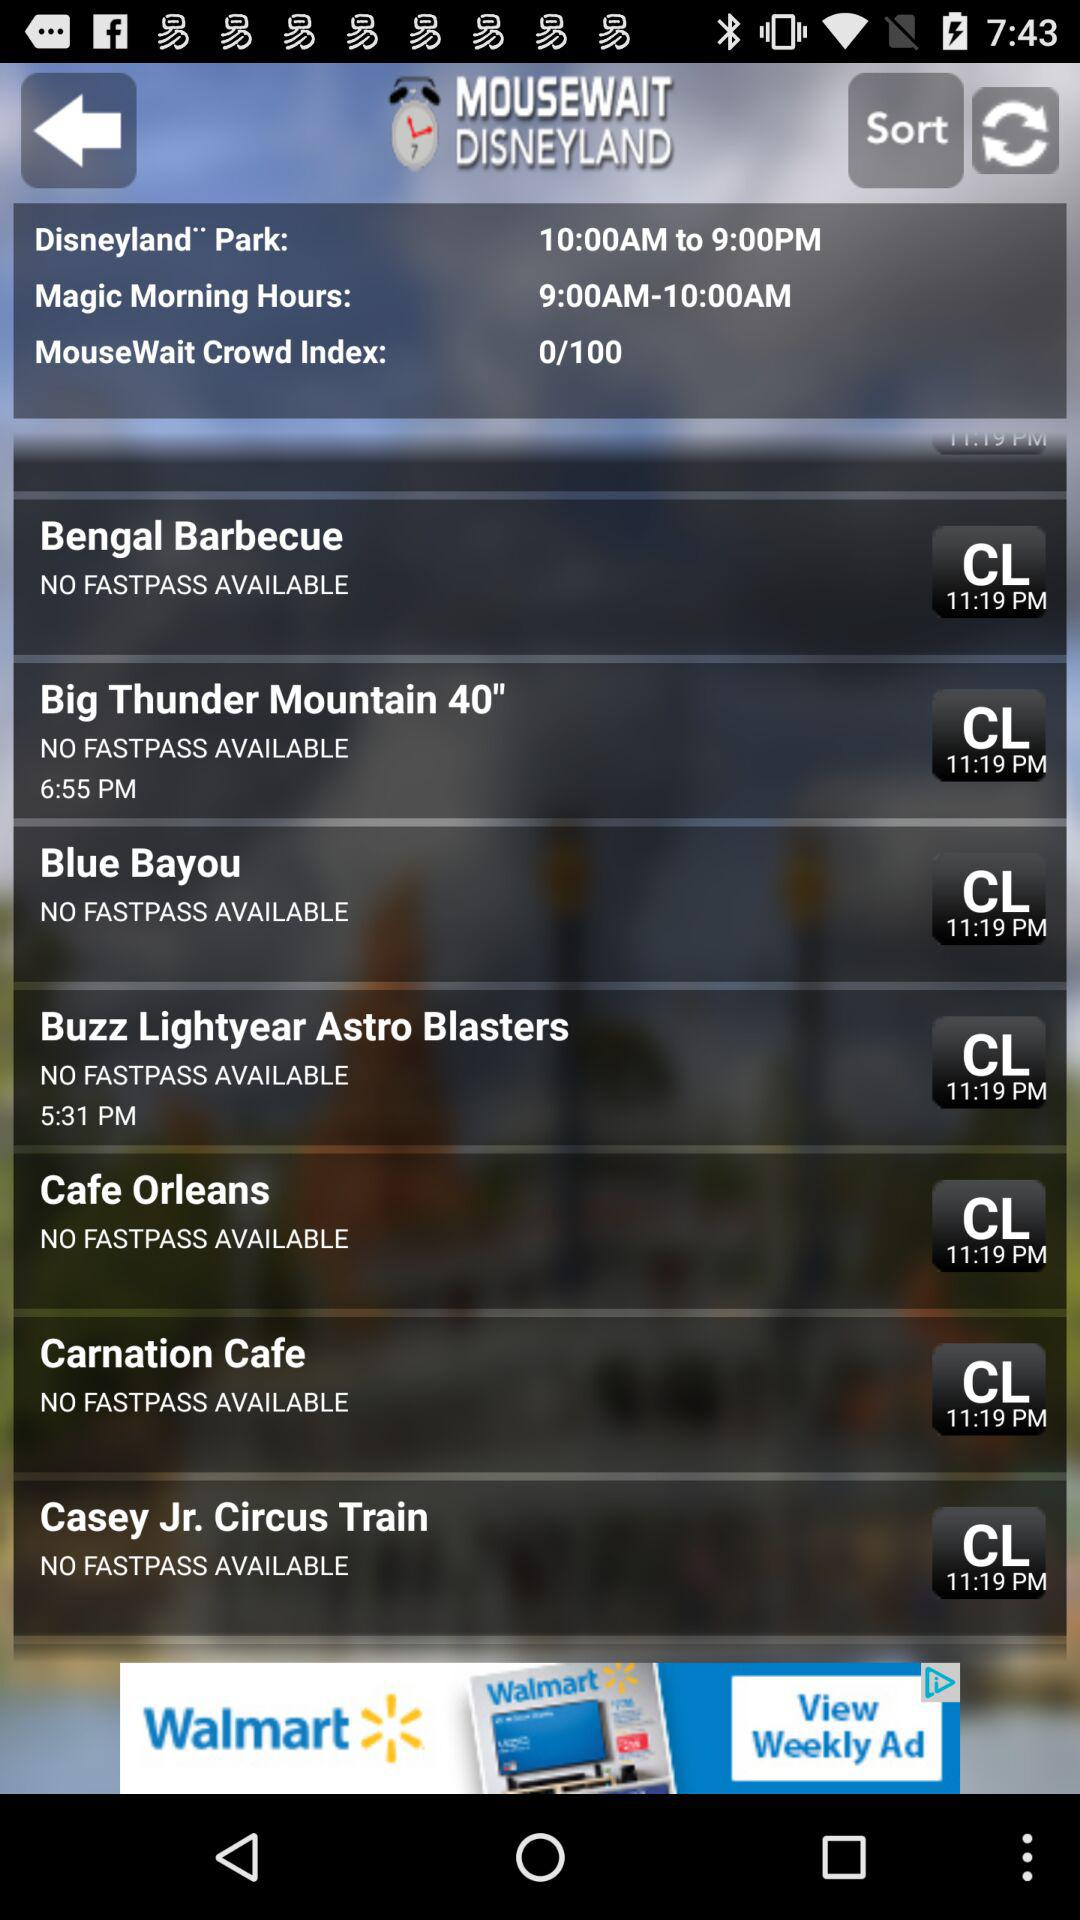What's the Closing time of the Park gaming Parlours?
When the provided information is insufficient, respond with <no answer>. <no answer> 